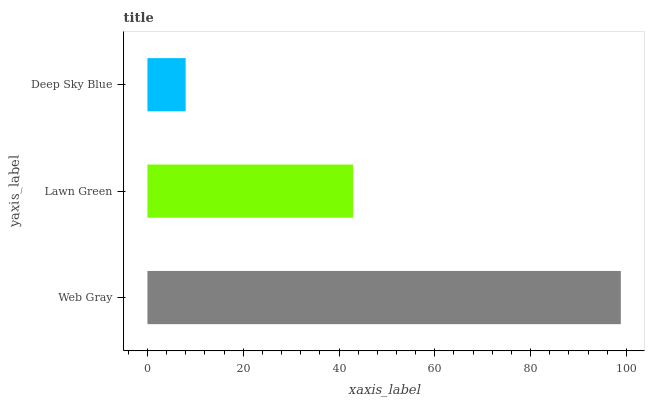Is Deep Sky Blue the minimum?
Answer yes or no. Yes. Is Web Gray the maximum?
Answer yes or no. Yes. Is Lawn Green the minimum?
Answer yes or no. No. Is Lawn Green the maximum?
Answer yes or no. No. Is Web Gray greater than Lawn Green?
Answer yes or no. Yes. Is Lawn Green less than Web Gray?
Answer yes or no. Yes. Is Lawn Green greater than Web Gray?
Answer yes or no. No. Is Web Gray less than Lawn Green?
Answer yes or no. No. Is Lawn Green the high median?
Answer yes or no. Yes. Is Lawn Green the low median?
Answer yes or no. Yes. Is Deep Sky Blue the high median?
Answer yes or no. No. Is Deep Sky Blue the low median?
Answer yes or no. No. 